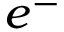Convert formula to latex. <formula><loc_0><loc_0><loc_500><loc_500>e ^ { - }</formula> 